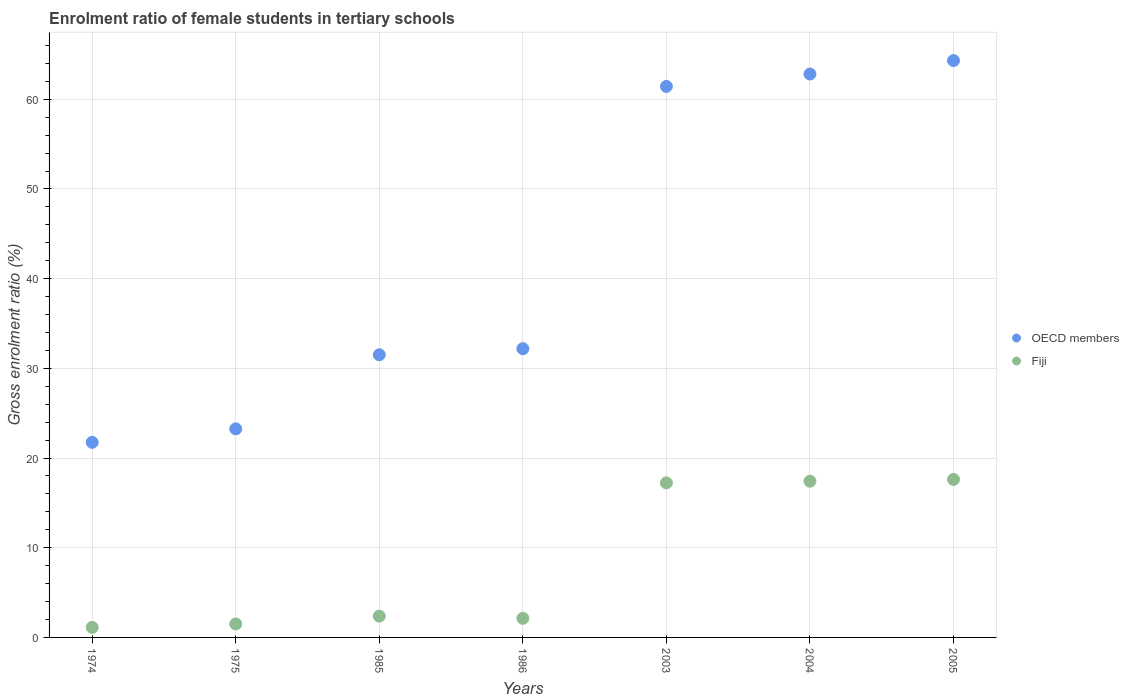How many different coloured dotlines are there?
Provide a short and direct response. 2. Is the number of dotlines equal to the number of legend labels?
Provide a succinct answer. Yes. What is the enrolment ratio of female students in tertiary schools in Fiji in 1986?
Provide a succinct answer. 2.13. Across all years, what is the maximum enrolment ratio of female students in tertiary schools in Fiji?
Give a very brief answer. 17.62. Across all years, what is the minimum enrolment ratio of female students in tertiary schools in OECD members?
Offer a terse response. 21.75. In which year was the enrolment ratio of female students in tertiary schools in Fiji maximum?
Offer a very short reply. 2005. In which year was the enrolment ratio of female students in tertiary schools in OECD members minimum?
Ensure brevity in your answer.  1974. What is the total enrolment ratio of female students in tertiary schools in OECD members in the graph?
Provide a short and direct response. 297.3. What is the difference between the enrolment ratio of female students in tertiary schools in Fiji in 1985 and that in 2004?
Provide a succinct answer. -15.05. What is the difference between the enrolment ratio of female students in tertiary schools in OECD members in 2003 and the enrolment ratio of female students in tertiary schools in Fiji in 2005?
Give a very brief answer. 43.82. What is the average enrolment ratio of female students in tertiary schools in Fiji per year?
Ensure brevity in your answer.  8.49. In the year 1974, what is the difference between the enrolment ratio of female students in tertiary schools in OECD members and enrolment ratio of female students in tertiary schools in Fiji?
Offer a terse response. 20.63. What is the ratio of the enrolment ratio of female students in tertiary schools in OECD members in 1985 to that in 2004?
Make the answer very short. 0.5. What is the difference between the highest and the second highest enrolment ratio of female students in tertiary schools in OECD members?
Your response must be concise. 1.5. What is the difference between the highest and the lowest enrolment ratio of female students in tertiary schools in Fiji?
Offer a terse response. 16.5. In how many years, is the enrolment ratio of female students in tertiary schools in Fiji greater than the average enrolment ratio of female students in tertiary schools in Fiji taken over all years?
Your answer should be very brief. 3. Is the sum of the enrolment ratio of female students in tertiary schools in Fiji in 1975 and 2005 greater than the maximum enrolment ratio of female students in tertiary schools in OECD members across all years?
Keep it short and to the point. No. Does the enrolment ratio of female students in tertiary schools in Fiji monotonically increase over the years?
Your answer should be compact. No. Is the enrolment ratio of female students in tertiary schools in Fiji strictly less than the enrolment ratio of female students in tertiary schools in OECD members over the years?
Offer a very short reply. Yes. How many years are there in the graph?
Provide a succinct answer. 7. What is the difference between two consecutive major ticks on the Y-axis?
Provide a short and direct response. 10. Are the values on the major ticks of Y-axis written in scientific E-notation?
Provide a succinct answer. No. Where does the legend appear in the graph?
Keep it short and to the point. Center right. What is the title of the graph?
Keep it short and to the point. Enrolment ratio of female students in tertiary schools. What is the label or title of the Y-axis?
Ensure brevity in your answer.  Gross enrolment ratio (%). What is the Gross enrolment ratio (%) of OECD members in 1974?
Your answer should be compact. 21.75. What is the Gross enrolment ratio (%) in Fiji in 1974?
Offer a very short reply. 1.12. What is the Gross enrolment ratio (%) of OECD members in 1975?
Give a very brief answer. 23.26. What is the Gross enrolment ratio (%) in Fiji in 1975?
Your response must be concise. 1.5. What is the Gross enrolment ratio (%) in OECD members in 1985?
Your answer should be compact. 31.52. What is the Gross enrolment ratio (%) in Fiji in 1985?
Offer a terse response. 2.37. What is the Gross enrolment ratio (%) of OECD members in 1986?
Provide a short and direct response. 32.19. What is the Gross enrolment ratio (%) of Fiji in 1986?
Keep it short and to the point. 2.13. What is the Gross enrolment ratio (%) of OECD members in 2003?
Give a very brief answer. 61.44. What is the Gross enrolment ratio (%) in Fiji in 2003?
Offer a terse response. 17.23. What is the Gross enrolment ratio (%) in OECD members in 2004?
Your answer should be very brief. 62.82. What is the Gross enrolment ratio (%) in Fiji in 2004?
Provide a short and direct response. 17.42. What is the Gross enrolment ratio (%) in OECD members in 2005?
Provide a short and direct response. 64.32. What is the Gross enrolment ratio (%) of Fiji in 2005?
Ensure brevity in your answer.  17.62. Across all years, what is the maximum Gross enrolment ratio (%) in OECD members?
Keep it short and to the point. 64.32. Across all years, what is the maximum Gross enrolment ratio (%) in Fiji?
Ensure brevity in your answer.  17.62. Across all years, what is the minimum Gross enrolment ratio (%) of OECD members?
Offer a terse response. 21.75. Across all years, what is the minimum Gross enrolment ratio (%) of Fiji?
Make the answer very short. 1.12. What is the total Gross enrolment ratio (%) of OECD members in the graph?
Keep it short and to the point. 297.3. What is the total Gross enrolment ratio (%) in Fiji in the graph?
Give a very brief answer. 59.4. What is the difference between the Gross enrolment ratio (%) in OECD members in 1974 and that in 1975?
Your response must be concise. -1.5. What is the difference between the Gross enrolment ratio (%) of Fiji in 1974 and that in 1975?
Ensure brevity in your answer.  -0.38. What is the difference between the Gross enrolment ratio (%) of OECD members in 1974 and that in 1985?
Your response must be concise. -9.77. What is the difference between the Gross enrolment ratio (%) of Fiji in 1974 and that in 1985?
Provide a succinct answer. -1.25. What is the difference between the Gross enrolment ratio (%) in OECD members in 1974 and that in 1986?
Offer a terse response. -10.44. What is the difference between the Gross enrolment ratio (%) of Fiji in 1974 and that in 1986?
Ensure brevity in your answer.  -1.01. What is the difference between the Gross enrolment ratio (%) in OECD members in 1974 and that in 2003?
Your answer should be compact. -39.69. What is the difference between the Gross enrolment ratio (%) of Fiji in 1974 and that in 2003?
Keep it short and to the point. -16.11. What is the difference between the Gross enrolment ratio (%) of OECD members in 1974 and that in 2004?
Give a very brief answer. -41.07. What is the difference between the Gross enrolment ratio (%) of Fiji in 1974 and that in 2004?
Keep it short and to the point. -16.3. What is the difference between the Gross enrolment ratio (%) of OECD members in 1974 and that in 2005?
Provide a short and direct response. -42.57. What is the difference between the Gross enrolment ratio (%) in Fiji in 1974 and that in 2005?
Give a very brief answer. -16.5. What is the difference between the Gross enrolment ratio (%) in OECD members in 1975 and that in 1985?
Provide a short and direct response. -8.26. What is the difference between the Gross enrolment ratio (%) in Fiji in 1975 and that in 1985?
Provide a short and direct response. -0.87. What is the difference between the Gross enrolment ratio (%) in OECD members in 1975 and that in 1986?
Offer a very short reply. -8.94. What is the difference between the Gross enrolment ratio (%) of Fiji in 1975 and that in 1986?
Keep it short and to the point. -0.63. What is the difference between the Gross enrolment ratio (%) of OECD members in 1975 and that in 2003?
Give a very brief answer. -38.18. What is the difference between the Gross enrolment ratio (%) in Fiji in 1975 and that in 2003?
Your response must be concise. -15.73. What is the difference between the Gross enrolment ratio (%) of OECD members in 1975 and that in 2004?
Your answer should be compact. -39.57. What is the difference between the Gross enrolment ratio (%) of Fiji in 1975 and that in 2004?
Your answer should be very brief. -15.92. What is the difference between the Gross enrolment ratio (%) of OECD members in 1975 and that in 2005?
Your answer should be compact. -41.06. What is the difference between the Gross enrolment ratio (%) of Fiji in 1975 and that in 2005?
Your answer should be compact. -16.12. What is the difference between the Gross enrolment ratio (%) in OECD members in 1985 and that in 1986?
Your answer should be very brief. -0.67. What is the difference between the Gross enrolment ratio (%) in Fiji in 1985 and that in 1986?
Provide a succinct answer. 0.24. What is the difference between the Gross enrolment ratio (%) of OECD members in 1985 and that in 2003?
Make the answer very short. -29.92. What is the difference between the Gross enrolment ratio (%) in Fiji in 1985 and that in 2003?
Give a very brief answer. -14.86. What is the difference between the Gross enrolment ratio (%) of OECD members in 1985 and that in 2004?
Your response must be concise. -31.3. What is the difference between the Gross enrolment ratio (%) in Fiji in 1985 and that in 2004?
Your answer should be very brief. -15.05. What is the difference between the Gross enrolment ratio (%) of OECD members in 1985 and that in 2005?
Keep it short and to the point. -32.8. What is the difference between the Gross enrolment ratio (%) of Fiji in 1985 and that in 2005?
Offer a terse response. -15.25. What is the difference between the Gross enrolment ratio (%) of OECD members in 1986 and that in 2003?
Offer a very short reply. -29.24. What is the difference between the Gross enrolment ratio (%) in Fiji in 1986 and that in 2003?
Give a very brief answer. -15.1. What is the difference between the Gross enrolment ratio (%) of OECD members in 1986 and that in 2004?
Your response must be concise. -30.63. What is the difference between the Gross enrolment ratio (%) in Fiji in 1986 and that in 2004?
Ensure brevity in your answer.  -15.29. What is the difference between the Gross enrolment ratio (%) of OECD members in 1986 and that in 2005?
Make the answer very short. -32.12. What is the difference between the Gross enrolment ratio (%) in Fiji in 1986 and that in 2005?
Your response must be concise. -15.49. What is the difference between the Gross enrolment ratio (%) of OECD members in 2003 and that in 2004?
Give a very brief answer. -1.38. What is the difference between the Gross enrolment ratio (%) in Fiji in 2003 and that in 2004?
Give a very brief answer. -0.19. What is the difference between the Gross enrolment ratio (%) in OECD members in 2003 and that in 2005?
Your answer should be compact. -2.88. What is the difference between the Gross enrolment ratio (%) of Fiji in 2003 and that in 2005?
Make the answer very short. -0.38. What is the difference between the Gross enrolment ratio (%) of OECD members in 2004 and that in 2005?
Keep it short and to the point. -1.5. What is the difference between the Gross enrolment ratio (%) of Fiji in 2004 and that in 2005?
Ensure brevity in your answer.  -0.2. What is the difference between the Gross enrolment ratio (%) in OECD members in 1974 and the Gross enrolment ratio (%) in Fiji in 1975?
Give a very brief answer. 20.25. What is the difference between the Gross enrolment ratio (%) of OECD members in 1974 and the Gross enrolment ratio (%) of Fiji in 1985?
Provide a short and direct response. 19.38. What is the difference between the Gross enrolment ratio (%) of OECD members in 1974 and the Gross enrolment ratio (%) of Fiji in 1986?
Make the answer very short. 19.62. What is the difference between the Gross enrolment ratio (%) of OECD members in 1974 and the Gross enrolment ratio (%) of Fiji in 2003?
Give a very brief answer. 4.52. What is the difference between the Gross enrolment ratio (%) of OECD members in 1974 and the Gross enrolment ratio (%) of Fiji in 2004?
Your answer should be very brief. 4.33. What is the difference between the Gross enrolment ratio (%) of OECD members in 1974 and the Gross enrolment ratio (%) of Fiji in 2005?
Offer a terse response. 4.13. What is the difference between the Gross enrolment ratio (%) in OECD members in 1975 and the Gross enrolment ratio (%) in Fiji in 1985?
Offer a very short reply. 20.88. What is the difference between the Gross enrolment ratio (%) in OECD members in 1975 and the Gross enrolment ratio (%) in Fiji in 1986?
Offer a very short reply. 21.12. What is the difference between the Gross enrolment ratio (%) of OECD members in 1975 and the Gross enrolment ratio (%) of Fiji in 2003?
Give a very brief answer. 6.02. What is the difference between the Gross enrolment ratio (%) in OECD members in 1975 and the Gross enrolment ratio (%) in Fiji in 2004?
Give a very brief answer. 5.84. What is the difference between the Gross enrolment ratio (%) in OECD members in 1975 and the Gross enrolment ratio (%) in Fiji in 2005?
Your answer should be very brief. 5.64. What is the difference between the Gross enrolment ratio (%) in OECD members in 1985 and the Gross enrolment ratio (%) in Fiji in 1986?
Ensure brevity in your answer.  29.39. What is the difference between the Gross enrolment ratio (%) in OECD members in 1985 and the Gross enrolment ratio (%) in Fiji in 2003?
Keep it short and to the point. 14.28. What is the difference between the Gross enrolment ratio (%) of OECD members in 1985 and the Gross enrolment ratio (%) of Fiji in 2004?
Provide a succinct answer. 14.1. What is the difference between the Gross enrolment ratio (%) in OECD members in 1985 and the Gross enrolment ratio (%) in Fiji in 2005?
Offer a very short reply. 13.9. What is the difference between the Gross enrolment ratio (%) of OECD members in 1986 and the Gross enrolment ratio (%) of Fiji in 2003?
Your answer should be compact. 14.96. What is the difference between the Gross enrolment ratio (%) of OECD members in 1986 and the Gross enrolment ratio (%) of Fiji in 2004?
Offer a terse response. 14.77. What is the difference between the Gross enrolment ratio (%) of OECD members in 1986 and the Gross enrolment ratio (%) of Fiji in 2005?
Give a very brief answer. 14.58. What is the difference between the Gross enrolment ratio (%) in OECD members in 2003 and the Gross enrolment ratio (%) in Fiji in 2004?
Give a very brief answer. 44.02. What is the difference between the Gross enrolment ratio (%) in OECD members in 2003 and the Gross enrolment ratio (%) in Fiji in 2005?
Offer a terse response. 43.82. What is the difference between the Gross enrolment ratio (%) in OECD members in 2004 and the Gross enrolment ratio (%) in Fiji in 2005?
Your response must be concise. 45.2. What is the average Gross enrolment ratio (%) of OECD members per year?
Your answer should be very brief. 42.47. What is the average Gross enrolment ratio (%) in Fiji per year?
Your response must be concise. 8.49. In the year 1974, what is the difference between the Gross enrolment ratio (%) of OECD members and Gross enrolment ratio (%) of Fiji?
Give a very brief answer. 20.63. In the year 1975, what is the difference between the Gross enrolment ratio (%) of OECD members and Gross enrolment ratio (%) of Fiji?
Your response must be concise. 21.76. In the year 1985, what is the difference between the Gross enrolment ratio (%) of OECD members and Gross enrolment ratio (%) of Fiji?
Keep it short and to the point. 29.15. In the year 1986, what is the difference between the Gross enrolment ratio (%) in OECD members and Gross enrolment ratio (%) in Fiji?
Offer a very short reply. 30.06. In the year 2003, what is the difference between the Gross enrolment ratio (%) of OECD members and Gross enrolment ratio (%) of Fiji?
Make the answer very short. 44.2. In the year 2004, what is the difference between the Gross enrolment ratio (%) of OECD members and Gross enrolment ratio (%) of Fiji?
Your answer should be compact. 45.4. In the year 2005, what is the difference between the Gross enrolment ratio (%) in OECD members and Gross enrolment ratio (%) in Fiji?
Provide a succinct answer. 46.7. What is the ratio of the Gross enrolment ratio (%) in OECD members in 1974 to that in 1975?
Your answer should be compact. 0.94. What is the ratio of the Gross enrolment ratio (%) in Fiji in 1974 to that in 1975?
Provide a short and direct response. 0.75. What is the ratio of the Gross enrolment ratio (%) of OECD members in 1974 to that in 1985?
Offer a very short reply. 0.69. What is the ratio of the Gross enrolment ratio (%) of Fiji in 1974 to that in 1985?
Offer a very short reply. 0.47. What is the ratio of the Gross enrolment ratio (%) of OECD members in 1974 to that in 1986?
Provide a succinct answer. 0.68. What is the ratio of the Gross enrolment ratio (%) in Fiji in 1974 to that in 1986?
Offer a terse response. 0.53. What is the ratio of the Gross enrolment ratio (%) of OECD members in 1974 to that in 2003?
Offer a very short reply. 0.35. What is the ratio of the Gross enrolment ratio (%) of Fiji in 1974 to that in 2003?
Offer a terse response. 0.07. What is the ratio of the Gross enrolment ratio (%) of OECD members in 1974 to that in 2004?
Ensure brevity in your answer.  0.35. What is the ratio of the Gross enrolment ratio (%) in Fiji in 1974 to that in 2004?
Offer a very short reply. 0.06. What is the ratio of the Gross enrolment ratio (%) in OECD members in 1974 to that in 2005?
Offer a terse response. 0.34. What is the ratio of the Gross enrolment ratio (%) in Fiji in 1974 to that in 2005?
Ensure brevity in your answer.  0.06. What is the ratio of the Gross enrolment ratio (%) in OECD members in 1975 to that in 1985?
Offer a very short reply. 0.74. What is the ratio of the Gross enrolment ratio (%) in Fiji in 1975 to that in 1985?
Provide a short and direct response. 0.63. What is the ratio of the Gross enrolment ratio (%) of OECD members in 1975 to that in 1986?
Your answer should be very brief. 0.72. What is the ratio of the Gross enrolment ratio (%) of Fiji in 1975 to that in 1986?
Provide a succinct answer. 0.7. What is the ratio of the Gross enrolment ratio (%) in OECD members in 1975 to that in 2003?
Make the answer very short. 0.38. What is the ratio of the Gross enrolment ratio (%) of Fiji in 1975 to that in 2003?
Your answer should be compact. 0.09. What is the ratio of the Gross enrolment ratio (%) of OECD members in 1975 to that in 2004?
Your answer should be compact. 0.37. What is the ratio of the Gross enrolment ratio (%) of Fiji in 1975 to that in 2004?
Give a very brief answer. 0.09. What is the ratio of the Gross enrolment ratio (%) of OECD members in 1975 to that in 2005?
Make the answer very short. 0.36. What is the ratio of the Gross enrolment ratio (%) of Fiji in 1975 to that in 2005?
Offer a very short reply. 0.09. What is the ratio of the Gross enrolment ratio (%) of Fiji in 1985 to that in 1986?
Give a very brief answer. 1.11. What is the ratio of the Gross enrolment ratio (%) of OECD members in 1985 to that in 2003?
Your answer should be compact. 0.51. What is the ratio of the Gross enrolment ratio (%) of Fiji in 1985 to that in 2003?
Offer a very short reply. 0.14. What is the ratio of the Gross enrolment ratio (%) of OECD members in 1985 to that in 2004?
Provide a succinct answer. 0.5. What is the ratio of the Gross enrolment ratio (%) of Fiji in 1985 to that in 2004?
Provide a succinct answer. 0.14. What is the ratio of the Gross enrolment ratio (%) of OECD members in 1985 to that in 2005?
Offer a terse response. 0.49. What is the ratio of the Gross enrolment ratio (%) in Fiji in 1985 to that in 2005?
Make the answer very short. 0.13. What is the ratio of the Gross enrolment ratio (%) in OECD members in 1986 to that in 2003?
Your answer should be very brief. 0.52. What is the ratio of the Gross enrolment ratio (%) of Fiji in 1986 to that in 2003?
Ensure brevity in your answer.  0.12. What is the ratio of the Gross enrolment ratio (%) of OECD members in 1986 to that in 2004?
Ensure brevity in your answer.  0.51. What is the ratio of the Gross enrolment ratio (%) in Fiji in 1986 to that in 2004?
Provide a short and direct response. 0.12. What is the ratio of the Gross enrolment ratio (%) in OECD members in 1986 to that in 2005?
Provide a succinct answer. 0.5. What is the ratio of the Gross enrolment ratio (%) in Fiji in 1986 to that in 2005?
Make the answer very short. 0.12. What is the ratio of the Gross enrolment ratio (%) in OECD members in 2003 to that in 2005?
Provide a succinct answer. 0.96. What is the ratio of the Gross enrolment ratio (%) in Fiji in 2003 to that in 2005?
Make the answer very short. 0.98. What is the ratio of the Gross enrolment ratio (%) in OECD members in 2004 to that in 2005?
Keep it short and to the point. 0.98. What is the ratio of the Gross enrolment ratio (%) of Fiji in 2004 to that in 2005?
Offer a terse response. 0.99. What is the difference between the highest and the second highest Gross enrolment ratio (%) of OECD members?
Provide a succinct answer. 1.5. What is the difference between the highest and the second highest Gross enrolment ratio (%) of Fiji?
Give a very brief answer. 0.2. What is the difference between the highest and the lowest Gross enrolment ratio (%) of OECD members?
Keep it short and to the point. 42.57. What is the difference between the highest and the lowest Gross enrolment ratio (%) in Fiji?
Your answer should be very brief. 16.5. 